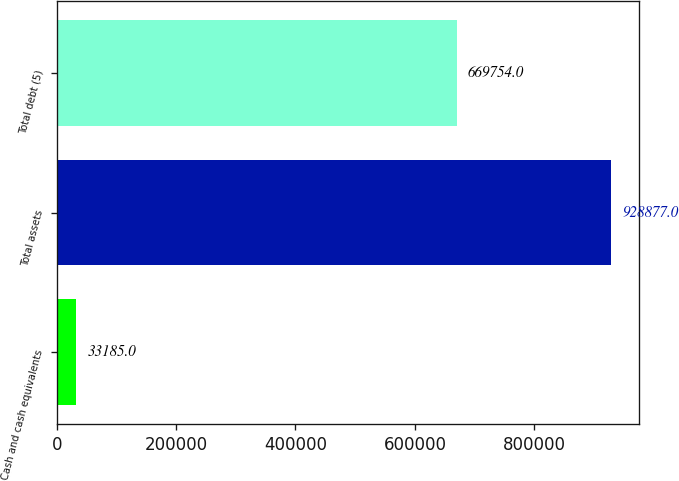Convert chart. <chart><loc_0><loc_0><loc_500><loc_500><bar_chart><fcel>Cash and cash equivalents<fcel>Total assets<fcel>Total debt (5)<nl><fcel>33185<fcel>928877<fcel>669754<nl></chart> 